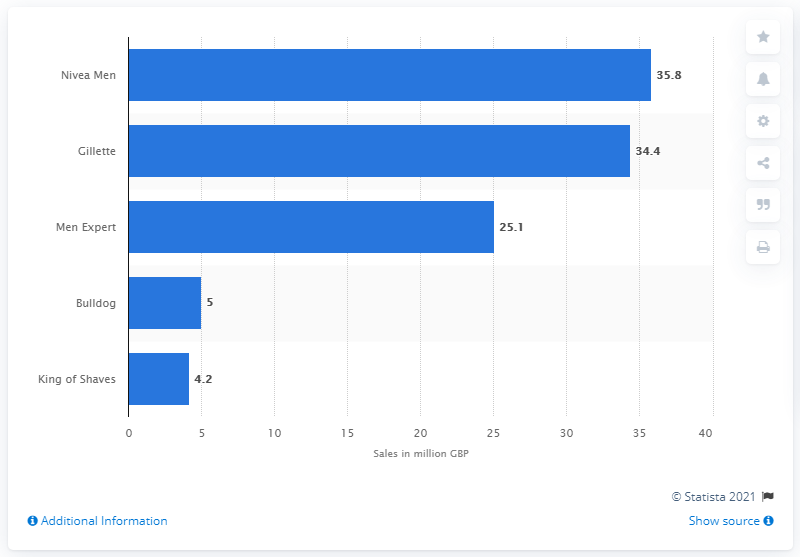List a handful of essential elements in this visual. Nivea Men is the number one men's skincare brand in the UK. Nivea Men generated sales of 35.8 pounds in the last quarter. 